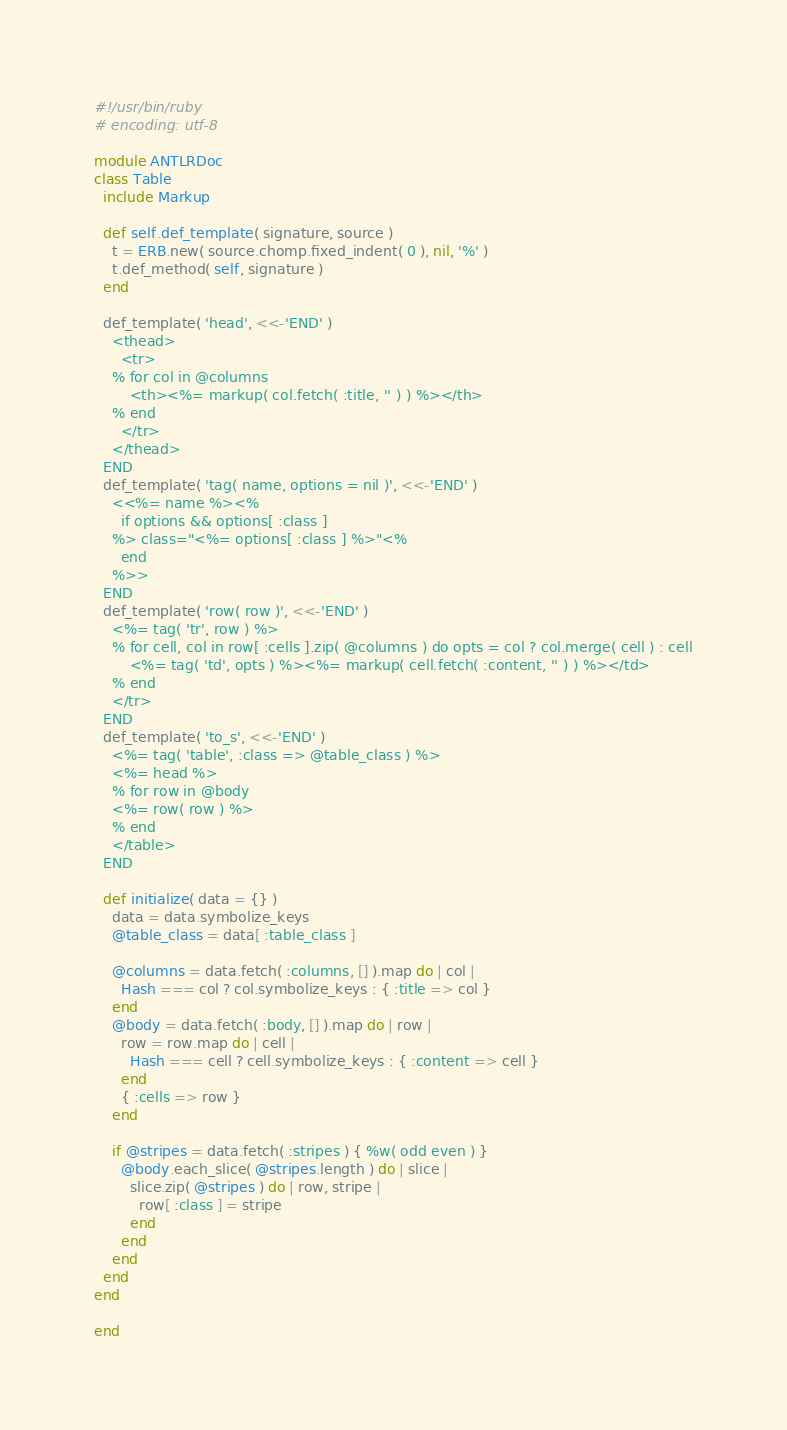<code> <loc_0><loc_0><loc_500><loc_500><_Ruby_>#!/usr/bin/ruby
# encoding: utf-8

module ANTLRDoc
class Table
  include Markup
  
  def self.def_template( signature, source )
    t = ERB.new( source.chomp.fixed_indent( 0 ), nil, '%' )
    t.def_method( self, signature )
  end
  
  def_template( 'head', <<-'END' )
    <thead>
      <tr>
    % for col in @columns
        <th><%= markup( col.fetch( :title, '' ) ) %></th>
    % end
      </tr>
    </thead>
  END
  def_template( 'tag( name, options = nil )', <<-'END' )
    <<%= name %><%
      if options && options[ :class ]
    %> class="<%= options[ :class ] %>"<%
      end
    %>>
  END
  def_template( 'row( row )', <<-'END' )
    <%= tag( 'tr', row ) %>
    % for cell, col in row[ :cells ].zip( @columns ) do opts = col ? col.merge( cell ) : cell
        <%= tag( 'td', opts ) %><%= markup( cell.fetch( :content, '' ) ) %></td>
    % end
    </tr>
  END
  def_template( 'to_s', <<-'END' )
    <%= tag( 'table', :class => @table_class ) %>
    <%= head %>
    % for row in @body
    <%= row( row ) %>
    % end
    </table>
  END
  
  def initialize( data = {} )
    data = data.symbolize_keys
    @table_class = data[ :table_class ]
    
    @columns = data.fetch( :columns, [] ).map do | col |
      Hash === col ? col.symbolize_keys : { :title => col }
    end
    @body = data.fetch( :body, [] ).map do | row |
      row = row.map do | cell |
        Hash === cell ? cell.symbolize_keys : { :content => cell }
      end
      { :cells => row }
    end
    
    if @stripes = data.fetch( :stripes ) { %w( odd even ) }
      @body.each_slice( @stripes.length ) do | slice |
        slice.zip( @stripes ) do | row, stripe |
          row[ :class ] = stripe
        end
      end
    end
  end
end
  
end
</code> 